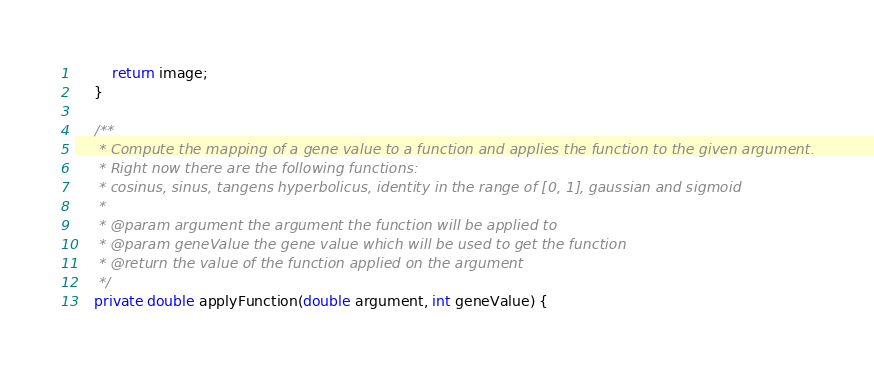<code> <loc_0><loc_0><loc_500><loc_500><_Java_>		return image;
	}
	
	/**
	 * Compute the mapping of a gene value to a function and applies the function to the given argument.
	 * Right now there are the following functions:
	 * cosinus, sinus, tangens hyperbolicus, identity in the range of [0, 1], gaussian and sigmoid   
	 * 
	 * @param argument the argument the function will be applied to
	 * @param geneValue the gene value which will be used to get the function
	 * @return the value of the function applied on the argument
	 */
	private double applyFunction(double argument, int geneValue) {</code> 